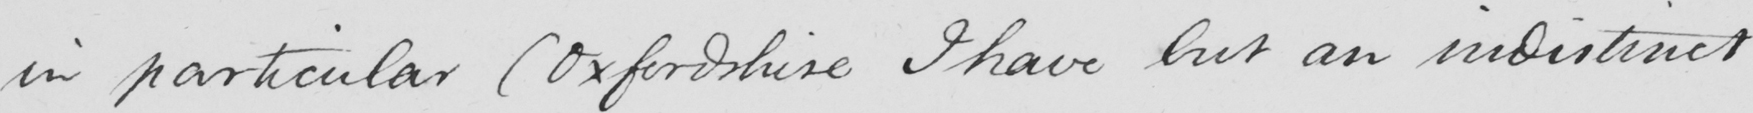Please provide the text content of this handwritten line. in particular  ( Oxfordshire I have but an indistinct 